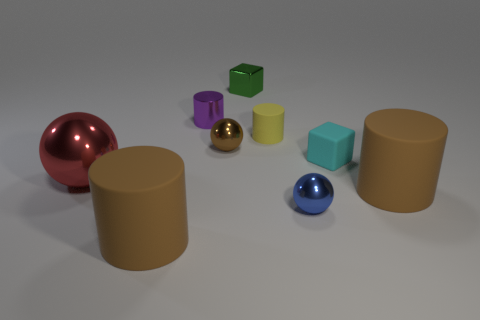How do the shadows cast by the objects inform us about the light source? The shadows in the image suggest that the light source is coming from the upper left corner of the scene. All the shadows of the objects are oriented towards the bottom right, indicating this directional light. The shadows also have soft edges, implying that the light source is not extremely close to the objects. 